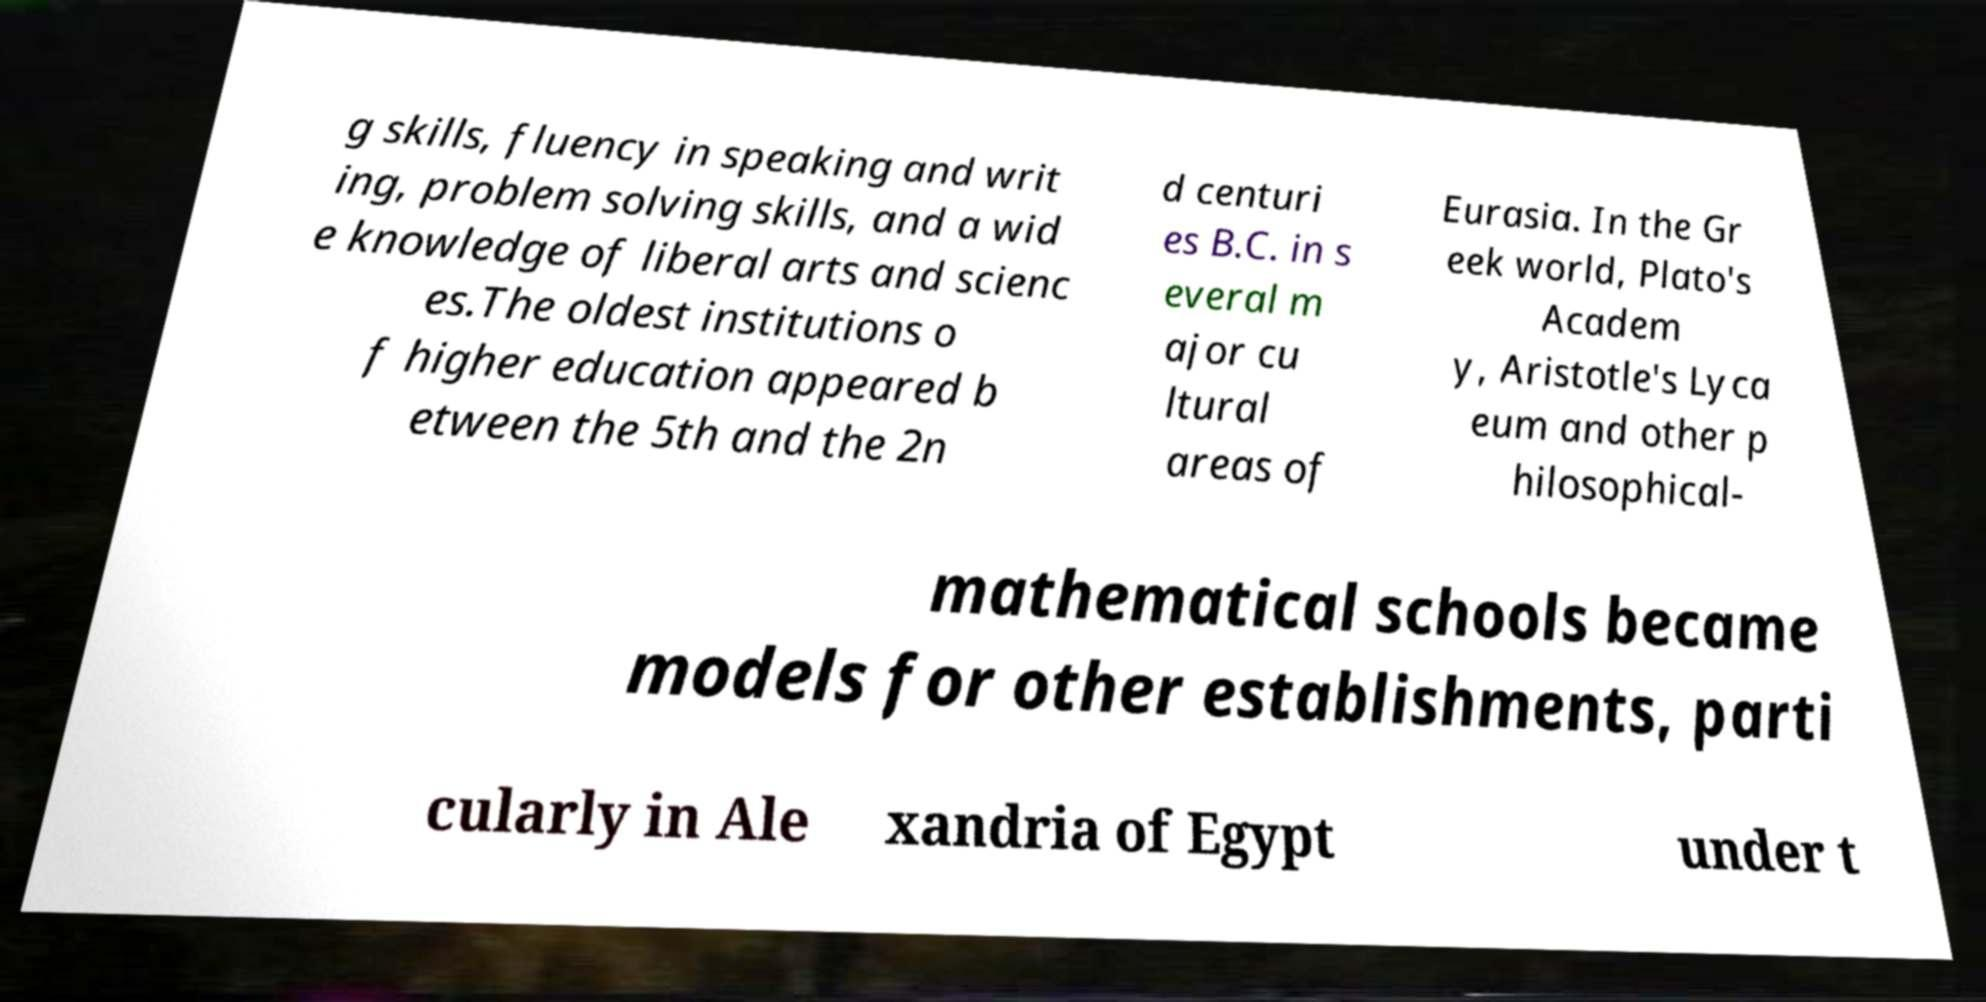Can you read and provide the text displayed in the image?This photo seems to have some interesting text. Can you extract and type it out for me? g skills, fluency in speaking and writ ing, problem solving skills, and a wid e knowledge of liberal arts and scienc es.The oldest institutions o f higher education appeared b etween the 5th and the 2n d centuri es B.C. in s everal m ajor cu ltural areas of Eurasia. In the Gr eek world, Plato's Academ y, Aristotle's Lyca eum and other p hilosophical- mathematical schools became models for other establishments, parti cularly in Ale xandria of Egypt under t 